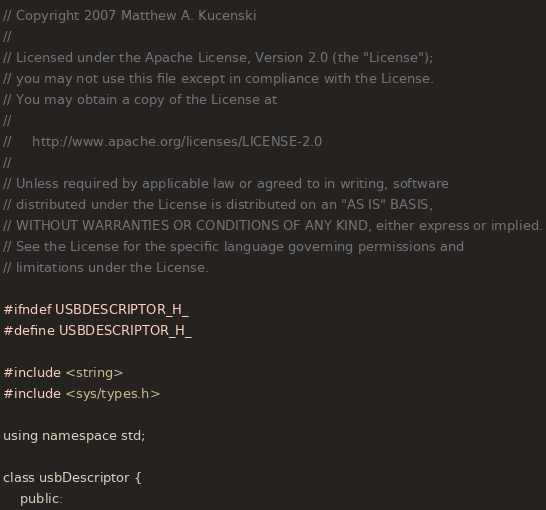Convert code to text. <code><loc_0><loc_0><loc_500><loc_500><_C_>// Copyright 2007 Matthew A. Kucenski
//
// Licensed under the Apache License, Version 2.0 (the "License");
// you may not use this file except in compliance with the License.
// You may obtain a copy of the License at
//
//     http://www.apache.org/licenses/LICENSE-2.0
//
// Unless required by applicable law or agreed to in writing, software
// distributed under the License is distributed on an "AS IS" BASIS,
// WITHOUT WARRANTIES OR CONDITIONS OF ANY KIND, either express or implied.
// See the License for the specific language governing permissions and
// limitations under the License.

#ifndef USBDESCRIPTOR_H_
#define USBDESCRIPTOR_H_

#include <string>
#include <sys/types.h>

using namespace std;

class usbDescriptor {
	public:</code> 